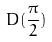<formula> <loc_0><loc_0><loc_500><loc_500>D ( \frac { \pi } { 2 } )</formula> 